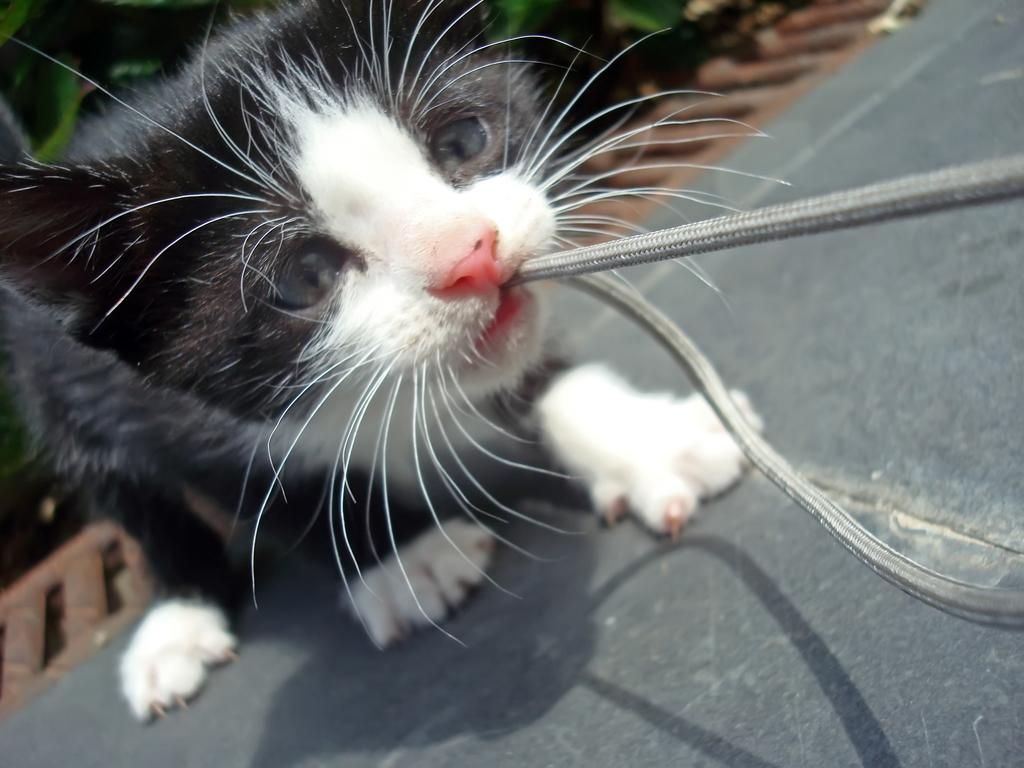What animal is present in the image? There is a cat in the image. What is the cat doing in the image? The cat is holding an object in its mouth. What can be seen at the bottom of the image? There is a road at the bottom of the image. What type of vegetable is the cat holding in its mouth? The cat is not holding a vegetable in its mouth; it is holding an unspecified object. How many quarters can be seen in the image? There are no quarters present in the image. 